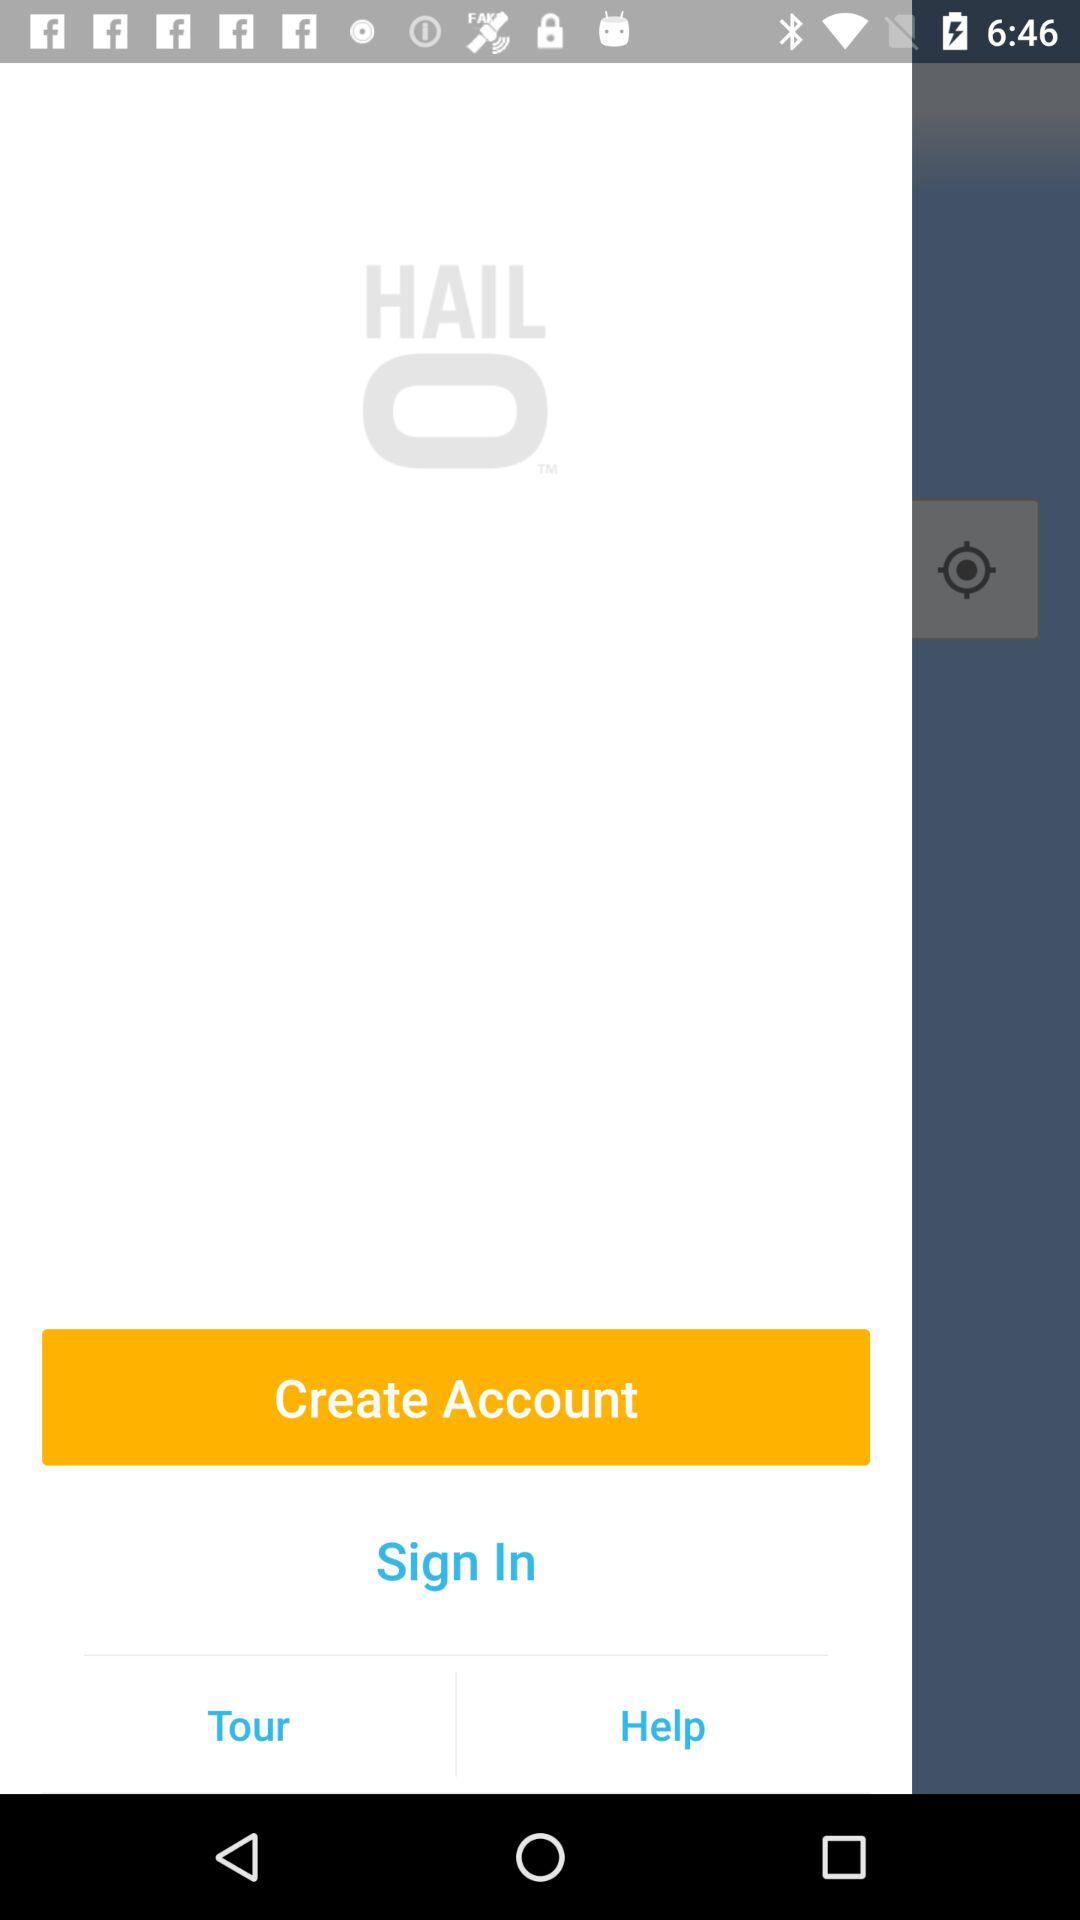What is the application name? The application name is "HAIL". 